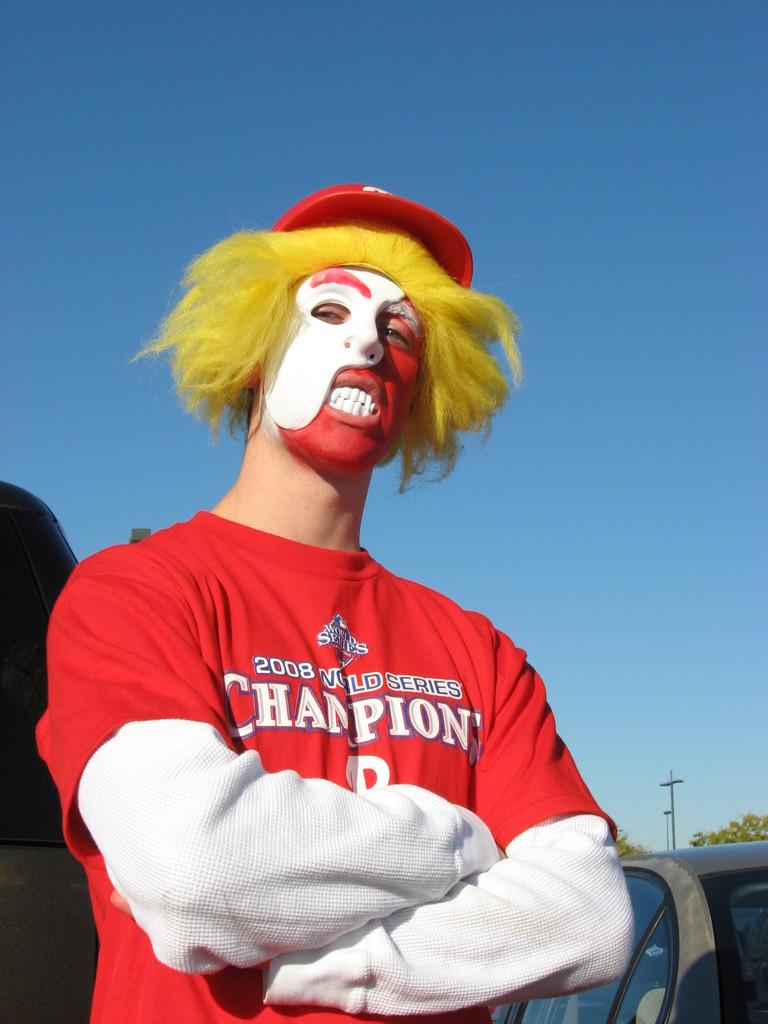What is on his shirt?
Provide a succinct answer. 2008 world series champions. What year did the phillies win the world series?
Offer a very short reply. 2008. 